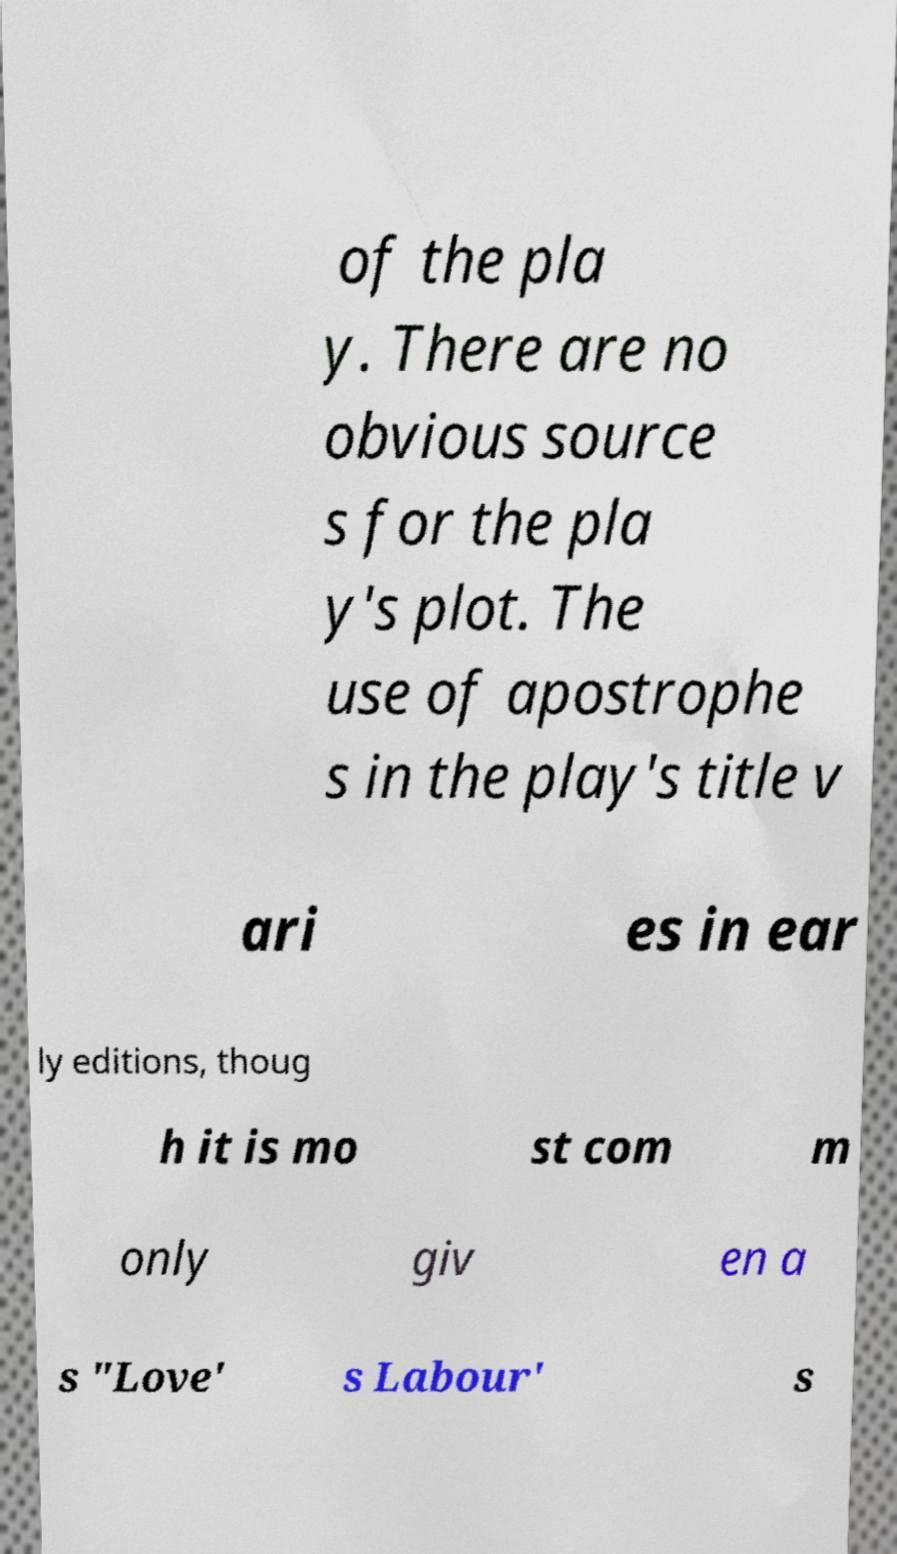Could you extract and type out the text from this image? of the pla y. There are no obvious source s for the pla y's plot. The use of apostrophe s in the play's title v ari es in ear ly editions, thoug h it is mo st com m only giv en a s "Love' s Labour' s 